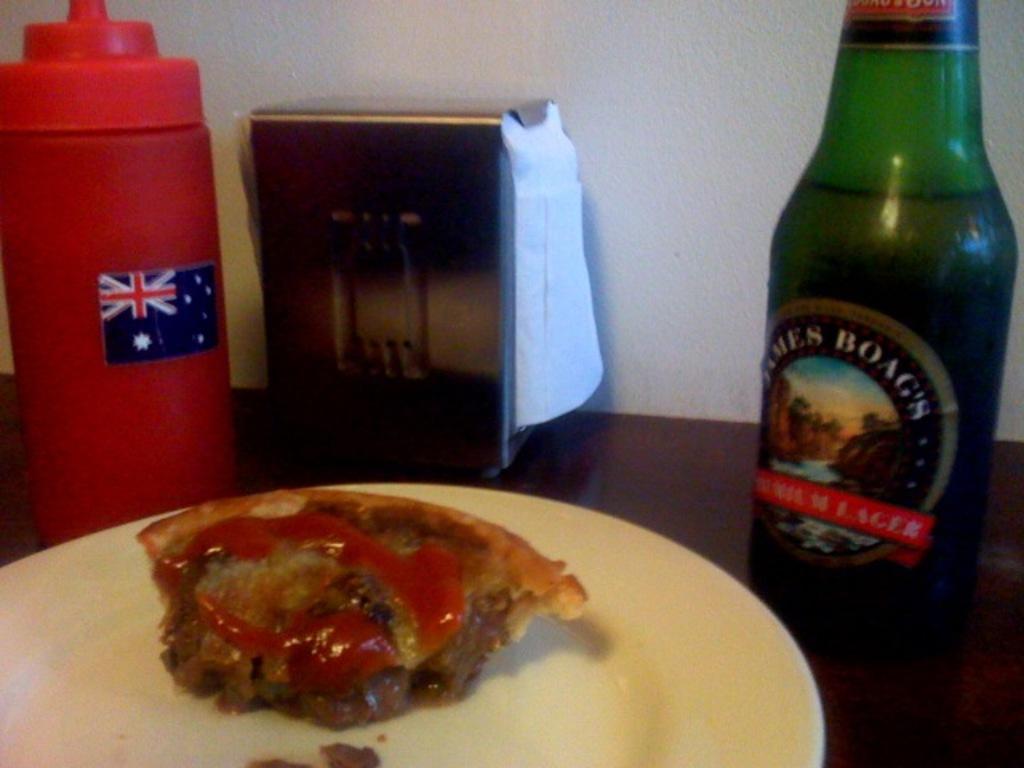Describe this image in one or two sentences. This image is clicked inside. On the right there is a bottle containing some drink which is placed on the top of the table. On the left there is a red color bottle seems to be containing a sauce and there is a stand next to that bottle. In the foreground there is a plate containing some food in it. In the background there is a wall. 